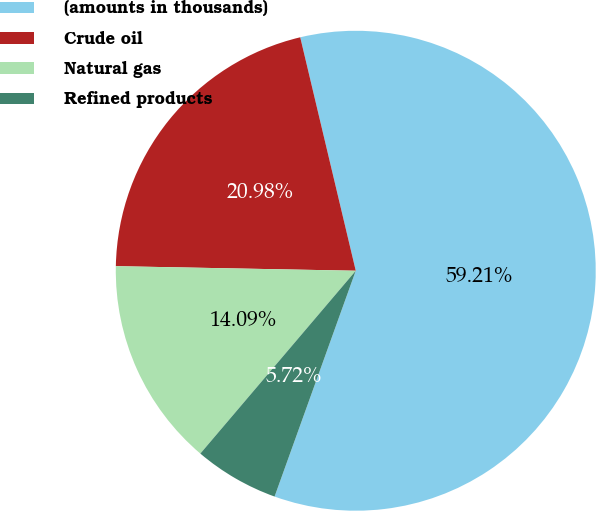<chart> <loc_0><loc_0><loc_500><loc_500><pie_chart><fcel>(amounts in thousands)<fcel>Crude oil<fcel>Natural gas<fcel>Refined products<nl><fcel>59.21%<fcel>20.98%<fcel>14.09%<fcel>5.72%<nl></chart> 